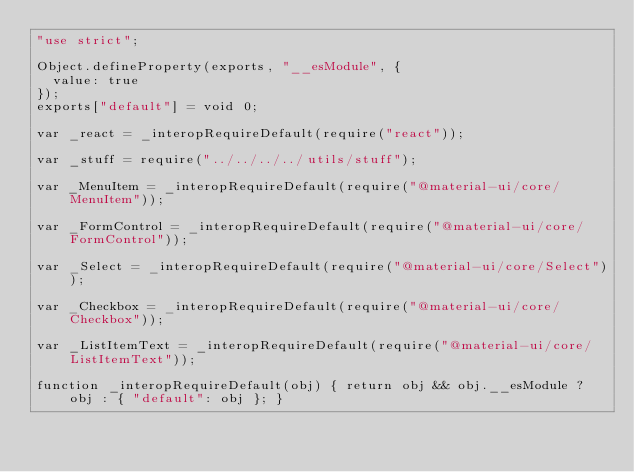<code> <loc_0><loc_0><loc_500><loc_500><_JavaScript_>"use strict";

Object.defineProperty(exports, "__esModule", {
  value: true
});
exports["default"] = void 0;

var _react = _interopRequireDefault(require("react"));

var _stuff = require("../../../../utils/stuff");

var _MenuItem = _interopRequireDefault(require("@material-ui/core/MenuItem"));

var _FormControl = _interopRequireDefault(require("@material-ui/core/FormControl"));

var _Select = _interopRequireDefault(require("@material-ui/core/Select"));

var _Checkbox = _interopRequireDefault(require("@material-ui/core/Checkbox"));

var _ListItemText = _interopRequireDefault(require("@material-ui/core/ListItemText"));

function _interopRequireDefault(obj) { return obj && obj.__esModule ? obj : { "default": obj }; }
</code> 